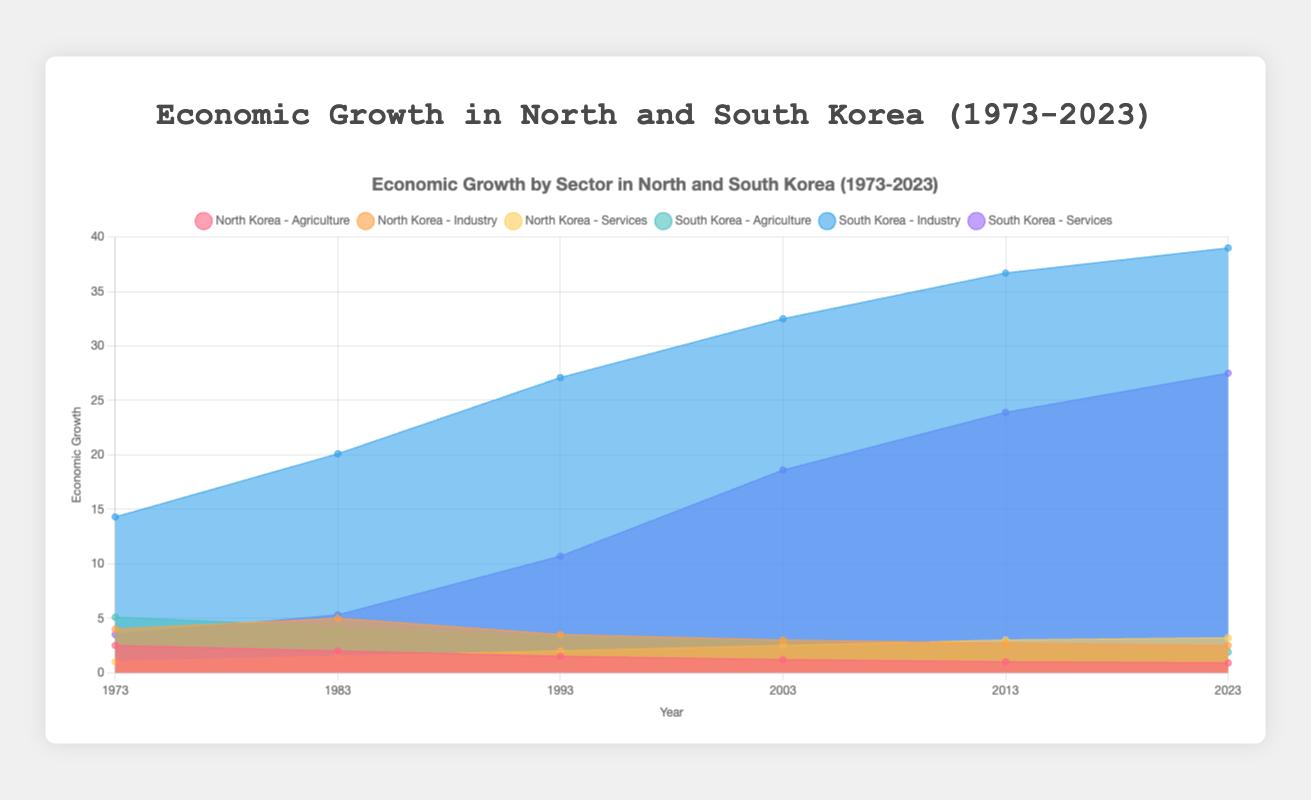What's the title of the figure? The title is displayed at the top of the figure and provides a summary of what the chart represents. The title is "Economic Growth in North and South Korea (1973-2023)".
Answer: Economic Growth in North and South Korea (1973-2023) What are the sectors represented in the chart? The chart has separate datasets for different sectors. These sectors are Agriculture, Industry, and Services.
Answer: Agriculture, Industry, Services How has the Agriculture sector in North Korea changed from 1973 to 2023? In 1973, the Agriculture sector's value for North Korea was 2.5. By 2023, it had decreased to 0.9. Therefore, there has been a declining trend.
Answer: Decreased Compare the Industry sector in South Korea in 1993 and 2023. In 1993, the Industry sector's value in South Korea was 27.1. In 2023, it increased to 39.0. This indicates significant growth.
Answer: Increased Which country had a higher value in the Services sector in 2023? In 2023, the Services sector value for North Korea was 3.2, while for South Korea it was 27.5. South Korea had a higher value.
Answer: South Korea Identify the time period when the Industry sector was highest for North Korea. By referring to the chart, we can see that the highest value for North Korea's Industry sector was in 1983 with a value of 5.0.
Answer: 1983 Across the years, did the Services sector ever surpass the Industry sector for North Korea? By examining the chart, we notice that in none of the years available does the Services sector exceed the Industry sector values for North Korea.
Answer: No What is the overall trend for the Services sector in South Korea from 1973 to 2023? From the data, the Services sector in South Korea has progressively increased from 3.5 in 1973 to 27.5 in 2023. This shows a strong upward trend.
Answer: Increasing Between 1993 and 2003, which country showed a more significant increase in Agriculture? For North Korea, the Agriculture sector decreased from 1.5 in 1993 to 1.2 in 2003, showing a decrease. For South Korea, it decreased from 3.3 in 1993 to 2.8 in 2003. Comparing these, South Korea experienced a less significant decrease than North Korea.
Answer: South Korea What year had the smallest gap between Industry sectors of North and South Korea? By examining the chart, 1973 shows the smallest gap where North Korea had 4.0 and South Korea had 14.3 in the Industry sector.
Answer: 1973 